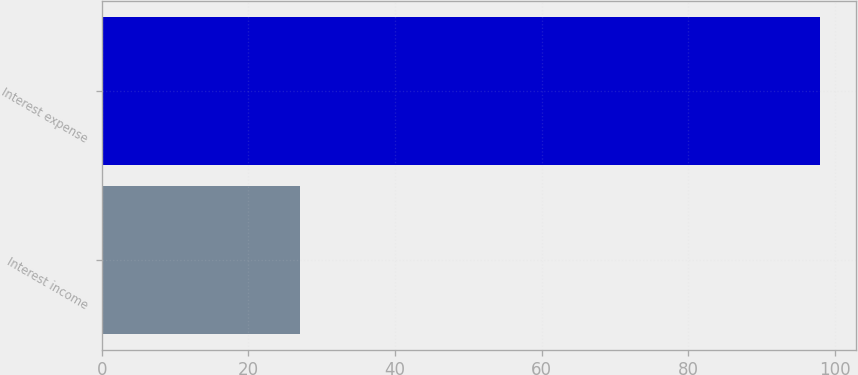Convert chart to OTSL. <chart><loc_0><loc_0><loc_500><loc_500><bar_chart><fcel>Interest income<fcel>Interest expense<nl><fcel>27<fcel>98<nl></chart> 